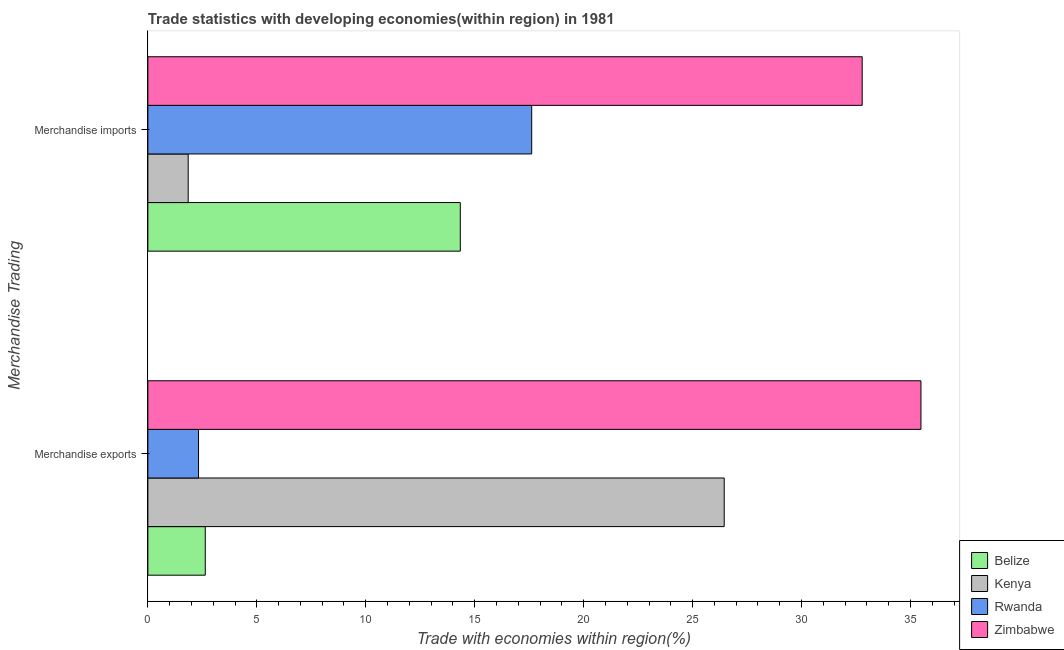Are the number of bars on each tick of the Y-axis equal?
Provide a short and direct response. Yes. How many bars are there on the 1st tick from the bottom?
Your answer should be very brief. 4. What is the label of the 1st group of bars from the top?
Provide a short and direct response. Merchandise imports. What is the merchandise exports in Rwanda?
Keep it short and to the point. 2.33. Across all countries, what is the maximum merchandise imports?
Your response must be concise. 32.78. Across all countries, what is the minimum merchandise exports?
Make the answer very short. 2.33. In which country was the merchandise imports maximum?
Your answer should be very brief. Zimbabwe. In which country was the merchandise imports minimum?
Ensure brevity in your answer.  Kenya. What is the total merchandise imports in the graph?
Your answer should be compact. 66.59. What is the difference between the merchandise exports in Rwanda and that in Kenya?
Offer a very short reply. -24.13. What is the difference between the merchandise exports in Belize and the merchandise imports in Rwanda?
Your answer should be compact. -14.98. What is the average merchandise imports per country?
Offer a terse response. 16.65. What is the difference between the merchandise imports and merchandise exports in Belize?
Provide a succinct answer. 11.7. What is the ratio of the merchandise exports in Belize to that in Rwanda?
Your answer should be very brief. 1.13. In how many countries, is the merchandise exports greater than the average merchandise exports taken over all countries?
Provide a succinct answer. 2. What does the 1st bar from the top in Merchandise imports represents?
Provide a succinct answer. Zimbabwe. What does the 3rd bar from the bottom in Merchandise exports represents?
Keep it short and to the point. Rwanda. How many bars are there?
Make the answer very short. 8. How many countries are there in the graph?
Ensure brevity in your answer.  4. What is the difference between two consecutive major ticks on the X-axis?
Ensure brevity in your answer.  5. Are the values on the major ticks of X-axis written in scientific E-notation?
Provide a short and direct response. No. Where does the legend appear in the graph?
Your answer should be compact. Bottom right. How many legend labels are there?
Make the answer very short. 4. What is the title of the graph?
Your answer should be very brief. Trade statistics with developing economies(within region) in 1981. What is the label or title of the X-axis?
Provide a short and direct response. Trade with economies within region(%). What is the label or title of the Y-axis?
Your response must be concise. Merchandise Trading. What is the Trade with economies within region(%) in Belize in Merchandise exports?
Keep it short and to the point. 2.63. What is the Trade with economies within region(%) in Kenya in Merchandise exports?
Offer a terse response. 26.45. What is the Trade with economies within region(%) of Rwanda in Merchandise exports?
Give a very brief answer. 2.33. What is the Trade with economies within region(%) of Zimbabwe in Merchandise exports?
Keep it short and to the point. 35.48. What is the Trade with economies within region(%) of Belize in Merchandise imports?
Provide a short and direct response. 14.34. What is the Trade with economies within region(%) of Kenya in Merchandise imports?
Make the answer very short. 1.85. What is the Trade with economies within region(%) in Rwanda in Merchandise imports?
Give a very brief answer. 17.62. What is the Trade with economies within region(%) of Zimbabwe in Merchandise imports?
Give a very brief answer. 32.78. Across all Merchandise Trading, what is the maximum Trade with economies within region(%) of Belize?
Give a very brief answer. 14.34. Across all Merchandise Trading, what is the maximum Trade with economies within region(%) of Kenya?
Your response must be concise. 26.45. Across all Merchandise Trading, what is the maximum Trade with economies within region(%) in Rwanda?
Keep it short and to the point. 17.62. Across all Merchandise Trading, what is the maximum Trade with economies within region(%) in Zimbabwe?
Offer a terse response. 35.48. Across all Merchandise Trading, what is the minimum Trade with economies within region(%) of Belize?
Offer a very short reply. 2.63. Across all Merchandise Trading, what is the minimum Trade with economies within region(%) of Kenya?
Your response must be concise. 1.85. Across all Merchandise Trading, what is the minimum Trade with economies within region(%) of Rwanda?
Provide a succinct answer. 2.33. Across all Merchandise Trading, what is the minimum Trade with economies within region(%) of Zimbabwe?
Keep it short and to the point. 32.78. What is the total Trade with economies within region(%) of Belize in the graph?
Provide a succinct answer. 16.97. What is the total Trade with economies within region(%) of Kenya in the graph?
Provide a succinct answer. 28.3. What is the total Trade with economies within region(%) in Rwanda in the graph?
Keep it short and to the point. 19.94. What is the total Trade with economies within region(%) of Zimbabwe in the graph?
Your response must be concise. 68.26. What is the difference between the Trade with economies within region(%) of Belize in Merchandise exports and that in Merchandise imports?
Provide a succinct answer. -11.7. What is the difference between the Trade with economies within region(%) of Kenya in Merchandise exports and that in Merchandise imports?
Provide a short and direct response. 24.6. What is the difference between the Trade with economies within region(%) in Rwanda in Merchandise exports and that in Merchandise imports?
Provide a succinct answer. -15.29. What is the difference between the Trade with economies within region(%) in Zimbabwe in Merchandise exports and that in Merchandise imports?
Your answer should be compact. 2.7. What is the difference between the Trade with economies within region(%) in Belize in Merchandise exports and the Trade with economies within region(%) in Kenya in Merchandise imports?
Offer a very short reply. 0.78. What is the difference between the Trade with economies within region(%) of Belize in Merchandise exports and the Trade with economies within region(%) of Rwanda in Merchandise imports?
Your response must be concise. -14.98. What is the difference between the Trade with economies within region(%) in Belize in Merchandise exports and the Trade with economies within region(%) in Zimbabwe in Merchandise imports?
Make the answer very short. -30.15. What is the difference between the Trade with economies within region(%) in Kenya in Merchandise exports and the Trade with economies within region(%) in Rwanda in Merchandise imports?
Your answer should be compact. 8.84. What is the difference between the Trade with economies within region(%) in Kenya in Merchandise exports and the Trade with economies within region(%) in Zimbabwe in Merchandise imports?
Ensure brevity in your answer.  -6.33. What is the difference between the Trade with economies within region(%) in Rwanda in Merchandise exports and the Trade with economies within region(%) in Zimbabwe in Merchandise imports?
Give a very brief answer. -30.46. What is the average Trade with economies within region(%) in Belize per Merchandise Trading?
Your answer should be compact. 8.49. What is the average Trade with economies within region(%) in Kenya per Merchandise Trading?
Your answer should be compact. 14.15. What is the average Trade with economies within region(%) in Rwanda per Merchandise Trading?
Your answer should be compact. 9.97. What is the average Trade with economies within region(%) of Zimbabwe per Merchandise Trading?
Make the answer very short. 34.13. What is the difference between the Trade with economies within region(%) in Belize and Trade with economies within region(%) in Kenya in Merchandise exports?
Offer a very short reply. -23.82. What is the difference between the Trade with economies within region(%) in Belize and Trade with economies within region(%) in Rwanda in Merchandise exports?
Give a very brief answer. 0.31. What is the difference between the Trade with economies within region(%) in Belize and Trade with economies within region(%) in Zimbabwe in Merchandise exports?
Offer a very short reply. -32.85. What is the difference between the Trade with economies within region(%) of Kenya and Trade with economies within region(%) of Rwanda in Merchandise exports?
Provide a short and direct response. 24.13. What is the difference between the Trade with economies within region(%) in Kenya and Trade with economies within region(%) in Zimbabwe in Merchandise exports?
Give a very brief answer. -9.03. What is the difference between the Trade with economies within region(%) in Rwanda and Trade with economies within region(%) in Zimbabwe in Merchandise exports?
Offer a terse response. -33.15. What is the difference between the Trade with economies within region(%) in Belize and Trade with economies within region(%) in Kenya in Merchandise imports?
Offer a terse response. 12.49. What is the difference between the Trade with economies within region(%) of Belize and Trade with economies within region(%) of Rwanda in Merchandise imports?
Ensure brevity in your answer.  -3.28. What is the difference between the Trade with economies within region(%) of Belize and Trade with economies within region(%) of Zimbabwe in Merchandise imports?
Make the answer very short. -18.44. What is the difference between the Trade with economies within region(%) of Kenya and Trade with economies within region(%) of Rwanda in Merchandise imports?
Your answer should be compact. -15.77. What is the difference between the Trade with economies within region(%) in Kenya and Trade with economies within region(%) in Zimbabwe in Merchandise imports?
Offer a terse response. -30.93. What is the difference between the Trade with economies within region(%) in Rwanda and Trade with economies within region(%) in Zimbabwe in Merchandise imports?
Make the answer very short. -15.17. What is the ratio of the Trade with economies within region(%) in Belize in Merchandise exports to that in Merchandise imports?
Your response must be concise. 0.18. What is the ratio of the Trade with economies within region(%) in Kenya in Merchandise exports to that in Merchandise imports?
Ensure brevity in your answer.  14.29. What is the ratio of the Trade with economies within region(%) in Rwanda in Merchandise exports to that in Merchandise imports?
Your answer should be compact. 0.13. What is the ratio of the Trade with economies within region(%) of Zimbabwe in Merchandise exports to that in Merchandise imports?
Your answer should be very brief. 1.08. What is the difference between the highest and the second highest Trade with economies within region(%) in Belize?
Provide a short and direct response. 11.7. What is the difference between the highest and the second highest Trade with economies within region(%) in Kenya?
Your response must be concise. 24.6. What is the difference between the highest and the second highest Trade with economies within region(%) of Rwanda?
Your response must be concise. 15.29. What is the difference between the highest and the second highest Trade with economies within region(%) in Zimbabwe?
Your answer should be compact. 2.7. What is the difference between the highest and the lowest Trade with economies within region(%) of Belize?
Offer a terse response. 11.7. What is the difference between the highest and the lowest Trade with economies within region(%) in Kenya?
Keep it short and to the point. 24.6. What is the difference between the highest and the lowest Trade with economies within region(%) of Rwanda?
Your answer should be very brief. 15.29. What is the difference between the highest and the lowest Trade with economies within region(%) of Zimbabwe?
Offer a very short reply. 2.7. 